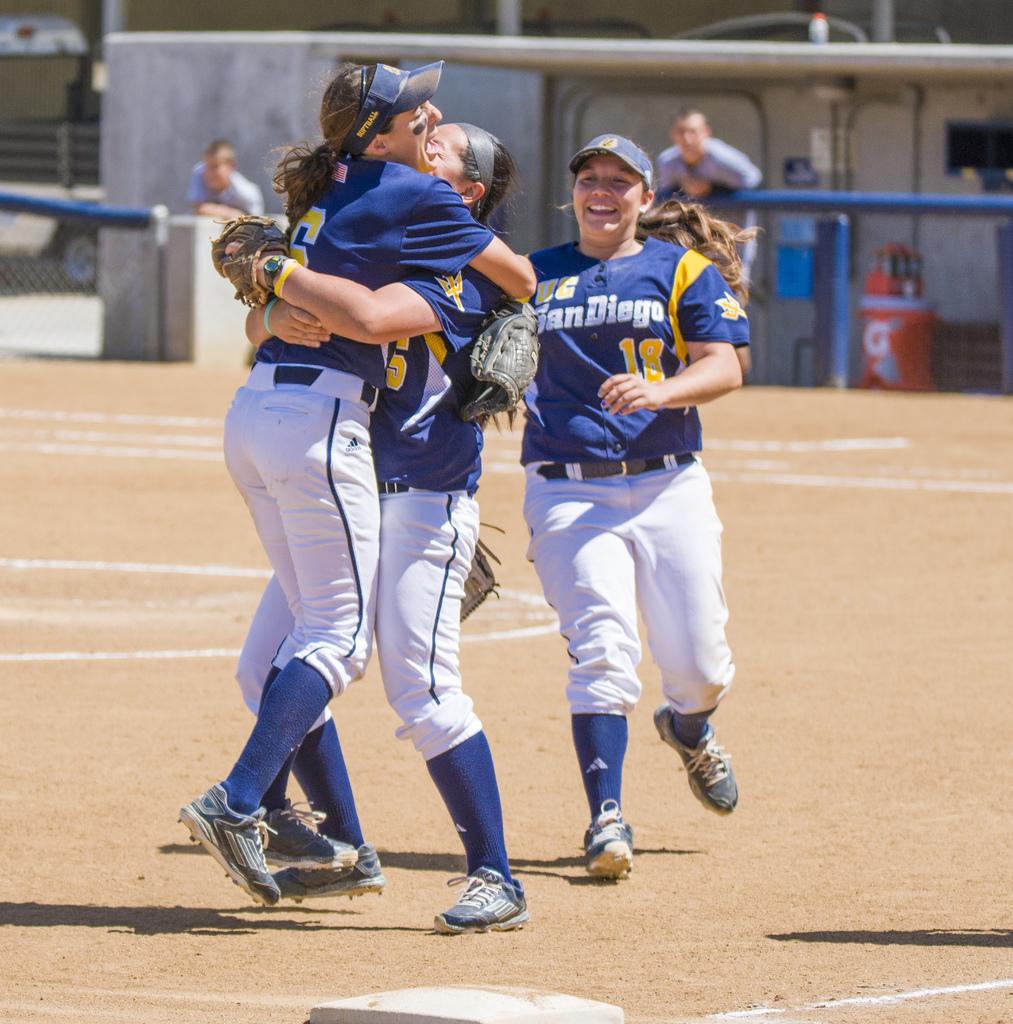What is the city of the baseball team?
Your answer should be compact. San diego. What is wrote above the city of number 18?
Your response must be concise. Uc. 